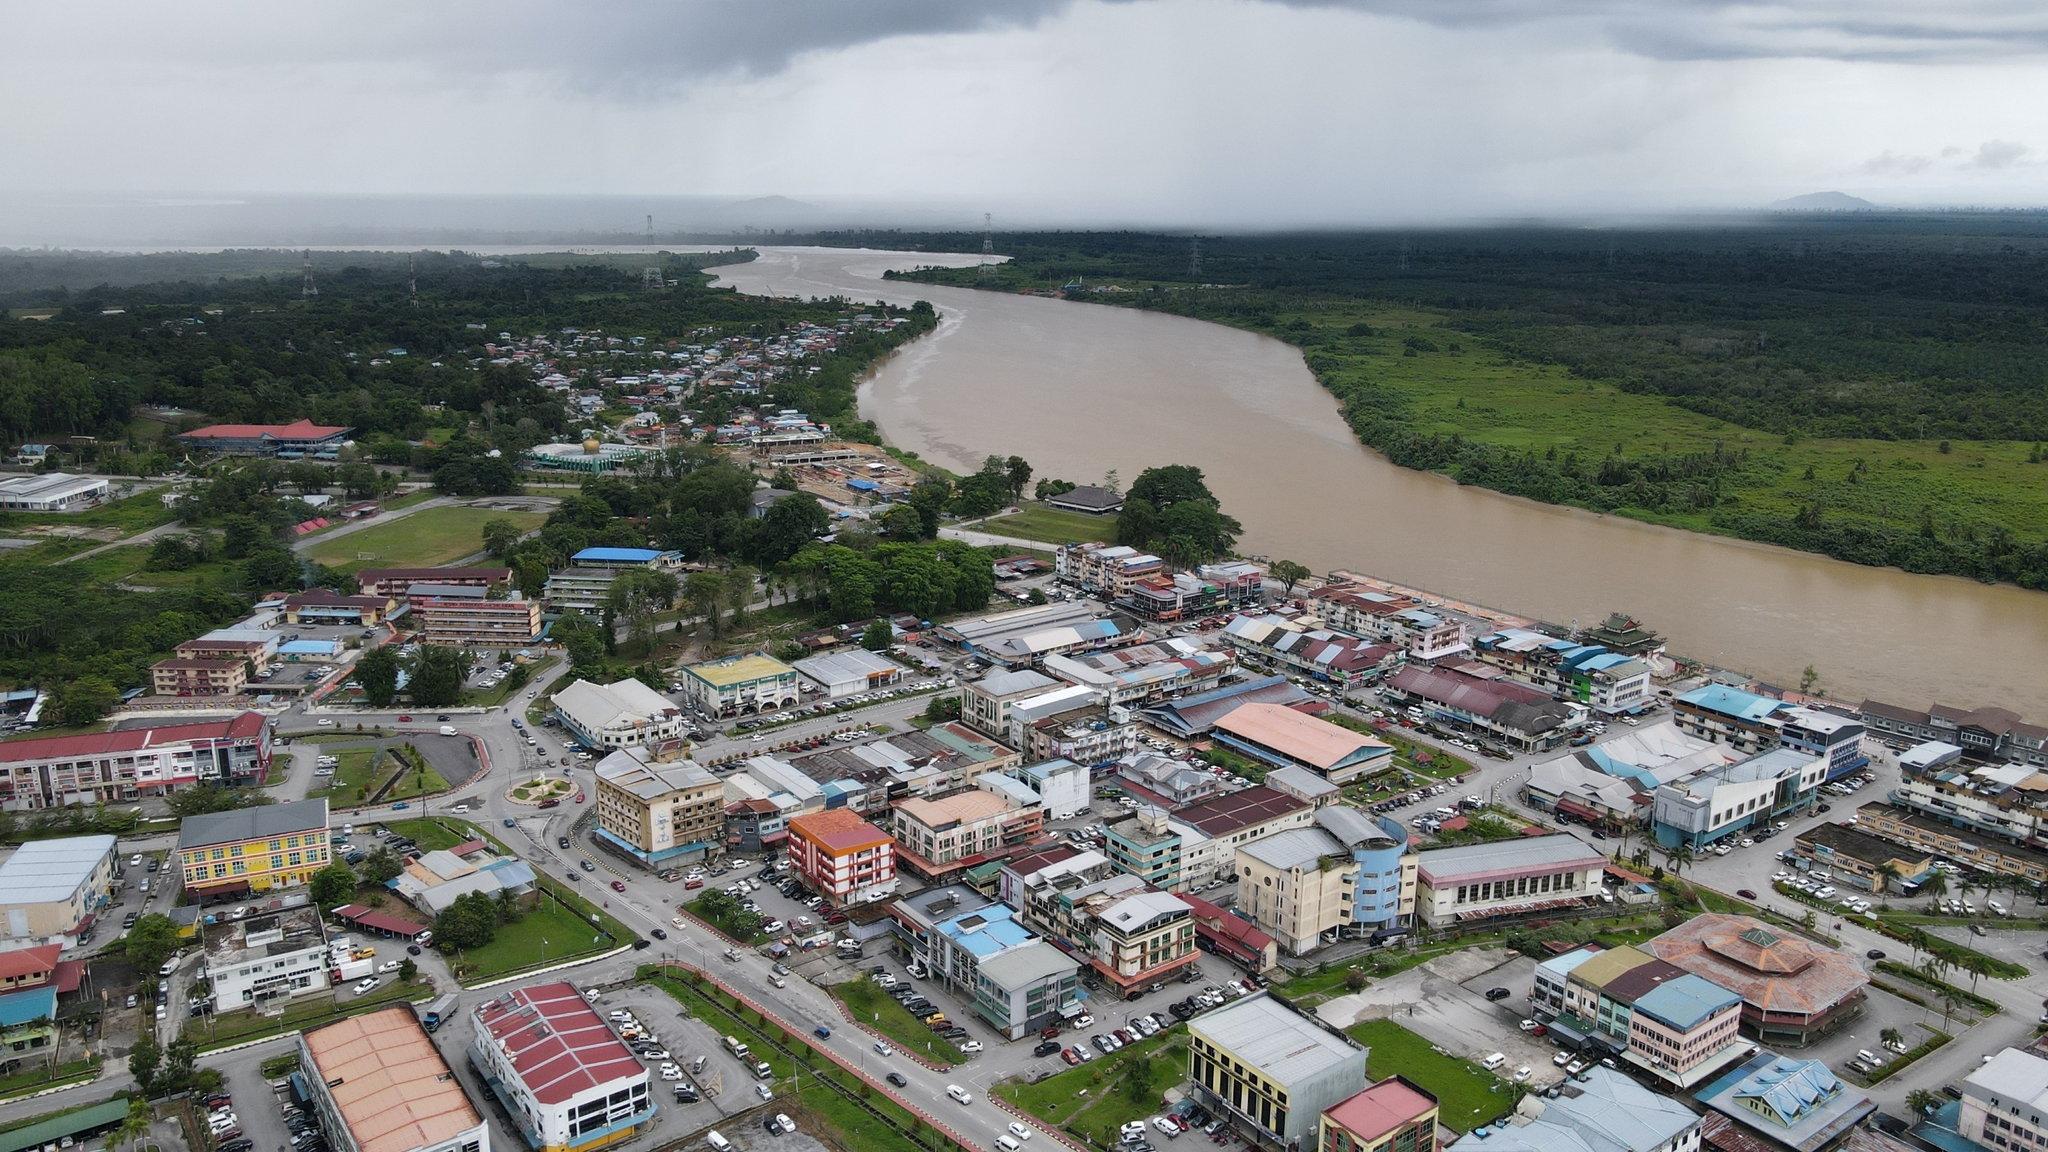What interesting historical events might have taken place in this town? This town, with its strategic location by a wide river, might have been a hub of trade and cultural exchange in its history. There could have been historical markets where traders from various regions came to sell goods, bringing with them unique stories and traditions. The river might have served as a vital route for transporting materials and connecting communities. During times of conflict, the town's location might have made it a strategic point, witnessing battles, treaties, and the rise and fall of local rulers. Over the centuries, the town may have evolved, developing rich cultural traditions and establishing historical landmarks that tell the tale of its vibrant past. 